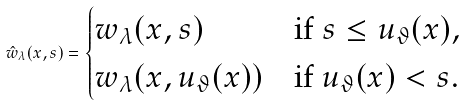<formula> <loc_0><loc_0><loc_500><loc_500>\hat { w } _ { \lambda } ( x , s ) = \begin{cases} w _ { \lambda } ( x , s ) & \text {if } s \leq u _ { \vartheta } ( x ) , \\ w _ { \lambda } ( x , u _ { \vartheta } ( x ) ) & \text {if } u _ { \vartheta } ( x ) < s . \end{cases}</formula> 